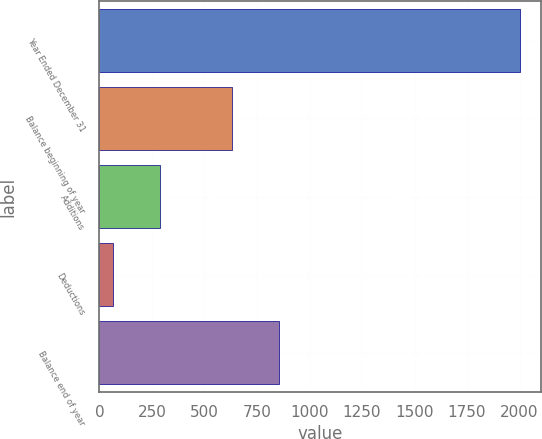Convert chart. <chart><loc_0><loc_0><loc_500><loc_500><bar_chart><fcel>Year Ended December 31<fcel>Balance beginning of year<fcel>Additions<fcel>Deductions<fcel>Balance end of year<nl><fcel>2004<fcel>630<fcel>291<fcel>67<fcel>854<nl></chart> 